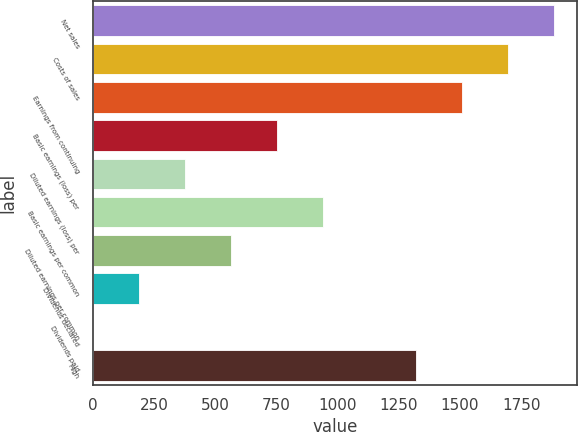Convert chart to OTSL. <chart><loc_0><loc_0><loc_500><loc_500><bar_chart><fcel>Net sales<fcel>Costs of sales<fcel>Earnings from continuing<fcel>Basic earnings (loss) per<fcel>Diluted earnings (loss) per<fcel>Basic earnings per common<fcel>Diluted earnings per common<fcel>Dividends declared<fcel>Dividends paid<fcel>High<nl><fcel>1883.01<fcel>1694.75<fcel>1506.49<fcel>753.45<fcel>376.93<fcel>941.71<fcel>565.19<fcel>188.67<fcel>0.41<fcel>1318.23<nl></chart> 